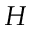<formula> <loc_0><loc_0><loc_500><loc_500>H</formula> 